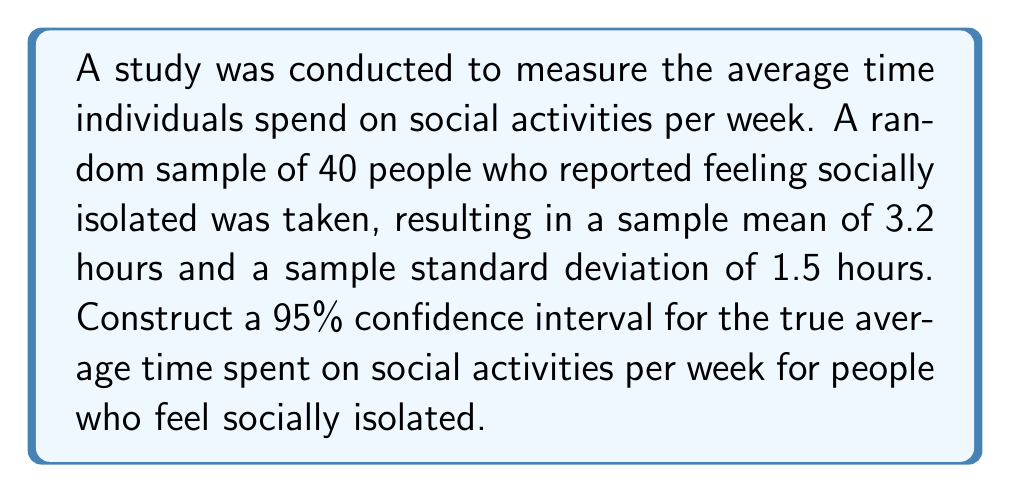Show me your answer to this math problem. To construct a 95% confidence interval for the population mean, we'll use the t-distribution since we don't know the population standard deviation. Here are the steps:

1. Identify the given information:
   - Sample size: $n = 40$
   - Sample mean: $\bar{x} = 3.2$ hours
   - Sample standard deviation: $s = 1.5$ hours
   - Confidence level: 95% (α = 0.05)

2. Find the critical t-value:
   - Degrees of freedom: $df = n - 1 = 40 - 1 = 39$
   - For a 95% confidence level and 39 df, $t_{0.025, 39} = 2.023$ (from t-table)

3. Calculate the standard error of the mean:
   $SE_{\bar{x}} = \frac{s}{\sqrt{n}} = \frac{1.5}{\sqrt{40}} = 0.237$

4. Compute the margin of error:
   $E = t_{0.025, 39} \times SE_{\bar{x}} = 2.023 \times 0.237 = 0.479$

5. Construct the confidence interval:
   $CI = \bar{x} \pm E = 3.2 \pm 0.479$
   
   Lower bound: $3.2 - 0.479 = 2.721$
   Upper bound: $3.2 + 0.479 = 3.679$

Therefore, the 95% confidence interval for the true average time spent on social activities per week is (2.721, 3.679) hours.
Answer: (2.721, 3.679) hours 